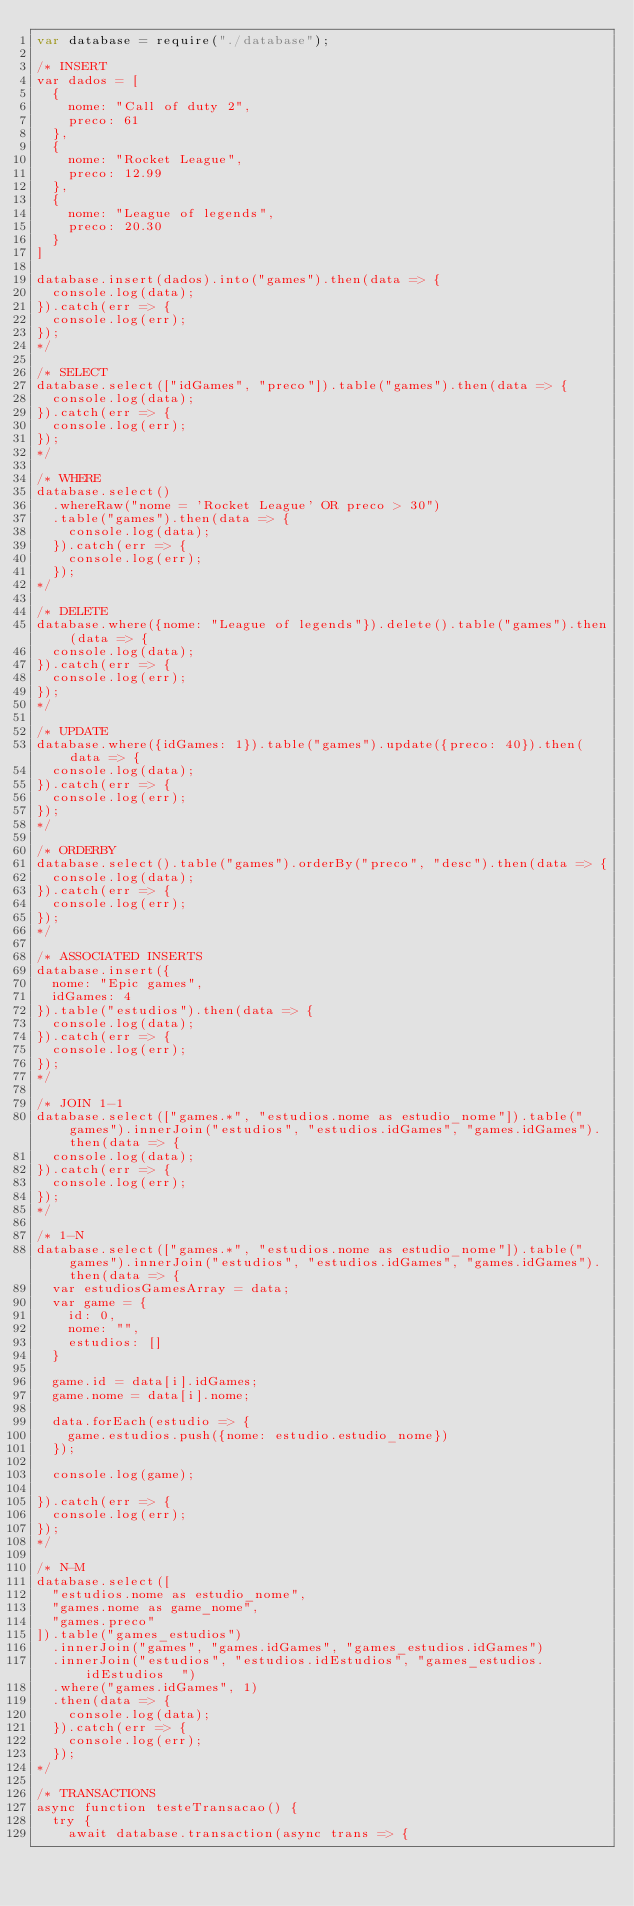<code> <loc_0><loc_0><loc_500><loc_500><_JavaScript_>var database = require("./database");

/* INSERT
var dados = [
  {
    nome: "Call of duty 2",
    preco: 61
  },
  {
    nome: "Rocket League",
    preco: 12.99
  },
  {
    nome: "League of legends",
    preco: 20.30
  }
]

database.insert(dados).into("games").then(data => {
  console.log(data);
}).catch(err => {
  console.log(err);
});
*/

/* SELECT
database.select(["idGames", "preco"]).table("games").then(data => {
  console.log(data);
}).catch(err => {
  console.log(err);
});
*/

/* WHERE
database.select()
  .whereRaw("nome = 'Rocket League' OR preco > 30")
  .table("games").then(data => {
    console.log(data);
  }).catch(err => {
    console.log(err);
  });
*/

/* DELETE
database.where({nome: "League of legends"}).delete().table("games").then(data => {
  console.log(data);
}).catch(err => {
  console.log(err);
});
*/

/* UPDATE
database.where({idGames: 1}).table("games").update({preco: 40}).then(data => {
  console.log(data);
}).catch(err => {
  console.log(err);
});
*/

/* ORDERBY
database.select().table("games").orderBy("preco", "desc").then(data => {
  console.log(data);
}).catch(err => {
  console.log(err);
});
*/

/* ASSOCIATED INSERTS
database.insert({
  nome: "Epic games",
  idGames: 4
}).table("estudios").then(data => {
  console.log(data);
}).catch(err => {
  console.log(err);
});
*/

/* JOIN 1-1
database.select(["games.*", "estudios.nome as estudio_nome"]).table("games").innerJoin("estudios", "estudios.idGames", "games.idGames").then(data => {
  console.log(data);
}).catch(err => {
  console.log(err);
});
*/

/* 1-N
database.select(["games.*", "estudios.nome as estudio_nome"]).table("games").innerJoin("estudios", "estudios.idGames", "games.idGames").then(data => {
  var estudiosGamesArray = data;
  var game = {
    id: 0,
    nome: "",
    estudios: []
  }

  game.id = data[i].idGames;
  game.nome = data[i].nome;

  data.forEach(estudio => {
    game.estudios.push({nome: estudio.estudio_nome})
  });

  console.log(game);

}).catch(err => {
  console.log(err);
});
*/

/* N-M
database.select([
  "estudios.nome as estudio_nome",
  "games.nome as game_nome",
  "games.preco"
]).table("games_estudios")
  .innerJoin("games", "games.idGames", "games_estudios.idGames")
  .innerJoin("estudios", "estudios.idEstudios", "games_estudios.idEstudios  ")
  .where("games.idGames", 1)
  .then(data => {
    console.log(data);
  }).catch(err => {
    console.log(err);
  });
*/

/* TRANSACTIONS
async function testeTransacao() {
  try {
    await database.transaction(async trans => {</code> 